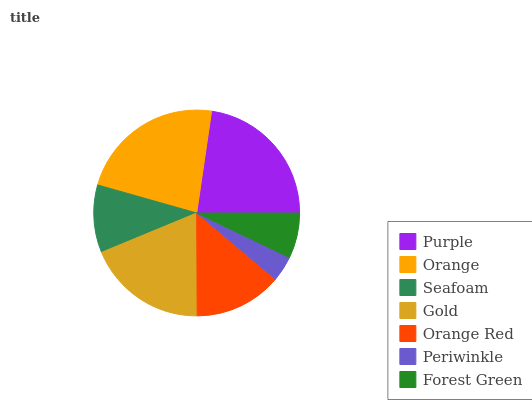Is Periwinkle the minimum?
Answer yes or no. Yes. Is Orange the maximum?
Answer yes or no. Yes. Is Seafoam the minimum?
Answer yes or no. No. Is Seafoam the maximum?
Answer yes or no. No. Is Orange greater than Seafoam?
Answer yes or no. Yes. Is Seafoam less than Orange?
Answer yes or no. Yes. Is Seafoam greater than Orange?
Answer yes or no. No. Is Orange less than Seafoam?
Answer yes or no. No. Is Orange Red the high median?
Answer yes or no. Yes. Is Orange Red the low median?
Answer yes or no. Yes. Is Seafoam the high median?
Answer yes or no. No. Is Orange the low median?
Answer yes or no. No. 